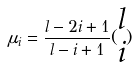Convert formula to latex. <formula><loc_0><loc_0><loc_500><loc_500>\mu _ { i } = \frac { l - 2 i + 1 } { l - i + 1 } ( \begin{matrix} l \\ i \end{matrix} )</formula> 